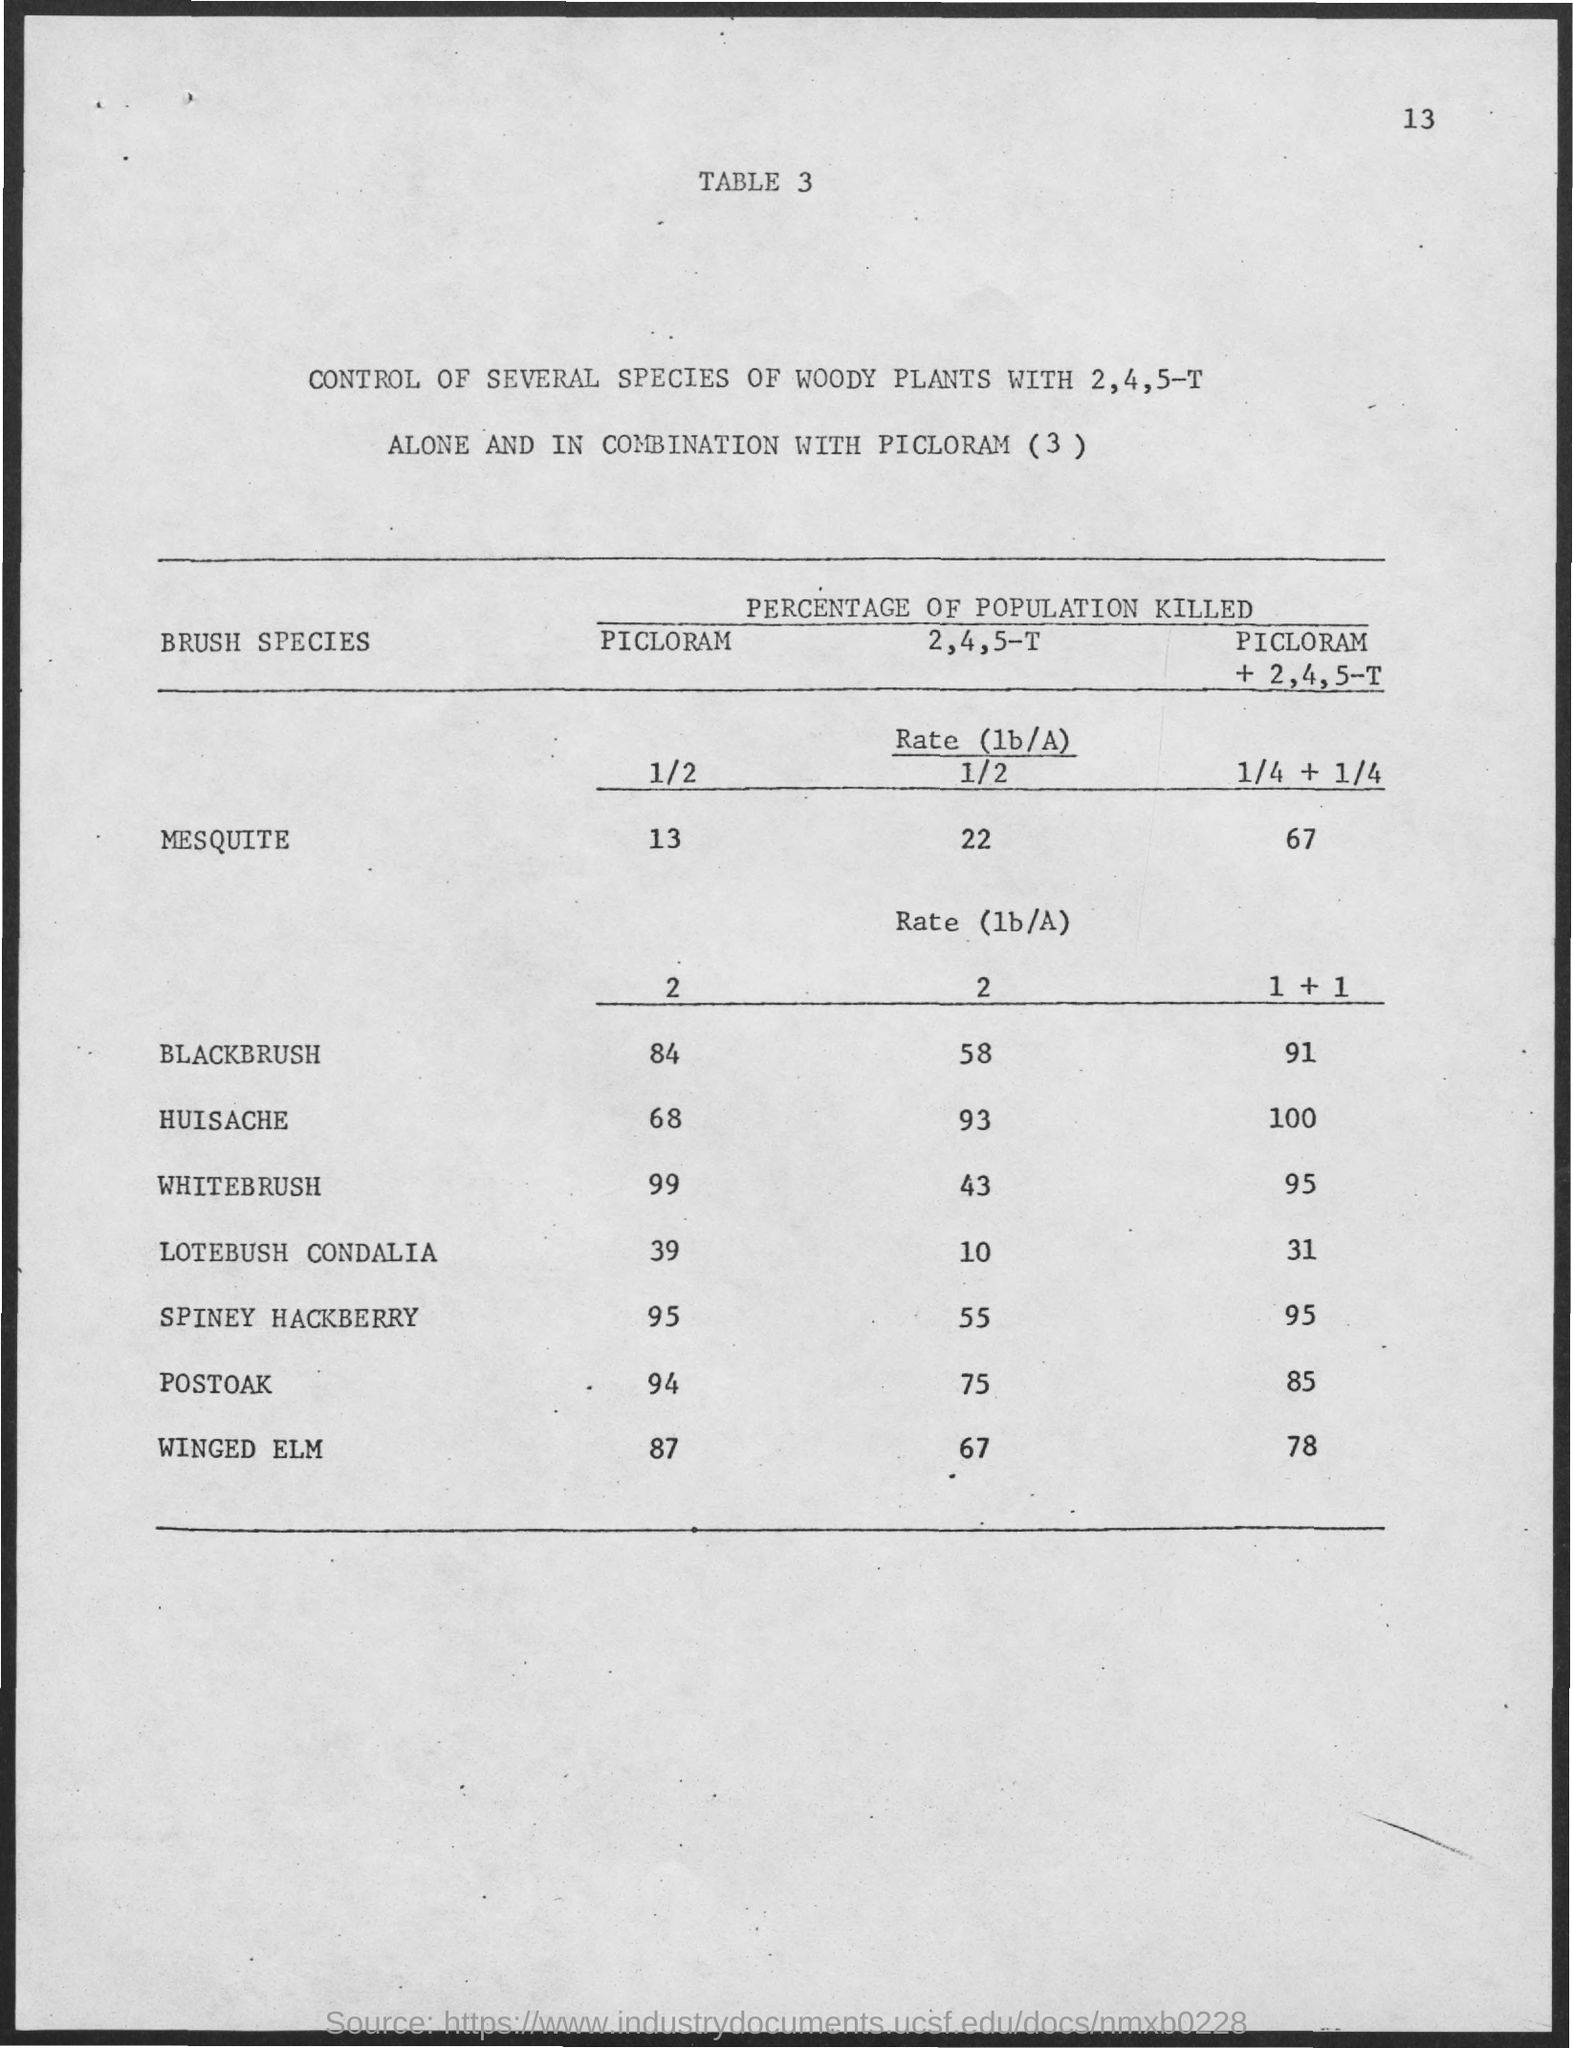Mention a couple of crucial points in this snapshot. After treatment with PICLORAM, 95% of the Spiney Hackberry trees exhibited signs of damage or death. A total of 84% of Blackbrush plants were killed by the application of PICLORAM. Nine-nine percent of Whitebrush was killed using PICLORAM. Thirty-nine percent of the Lotebush Condalia population was killed as a result of exposure to PICLORAM. A study has found that 43% of Whitebrush plants were killed when treated with a mixture of 2,4,5-T. 